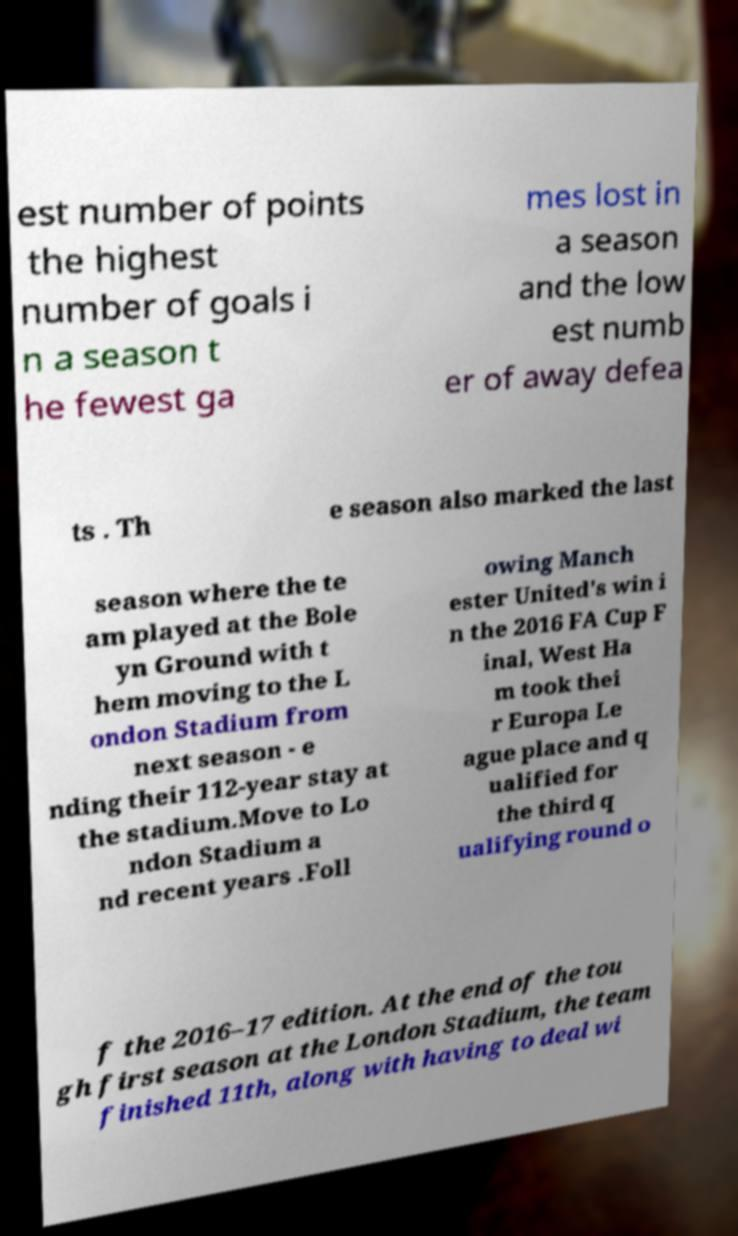Could you extract and type out the text from this image? est number of points the highest number of goals i n a season t he fewest ga mes lost in a season and the low est numb er of away defea ts . Th e season also marked the last season where the te am played at the Bole yn Ground with t hem moving to the L ondon Stadium from next season - e nding their 112-year stay at the stadium.Move to Lo ndon Stadium a nd recent years .Foll owing Manch ester United's win i n the 2016 FA Cup F inal, West Ha m took thei r Europa Le ague place and q ualified for the third q ualifying round o f the 2016–17 edition. At the end of the tou gh first season at the London Stadium, the team finished 11th, along with having to deal wi 